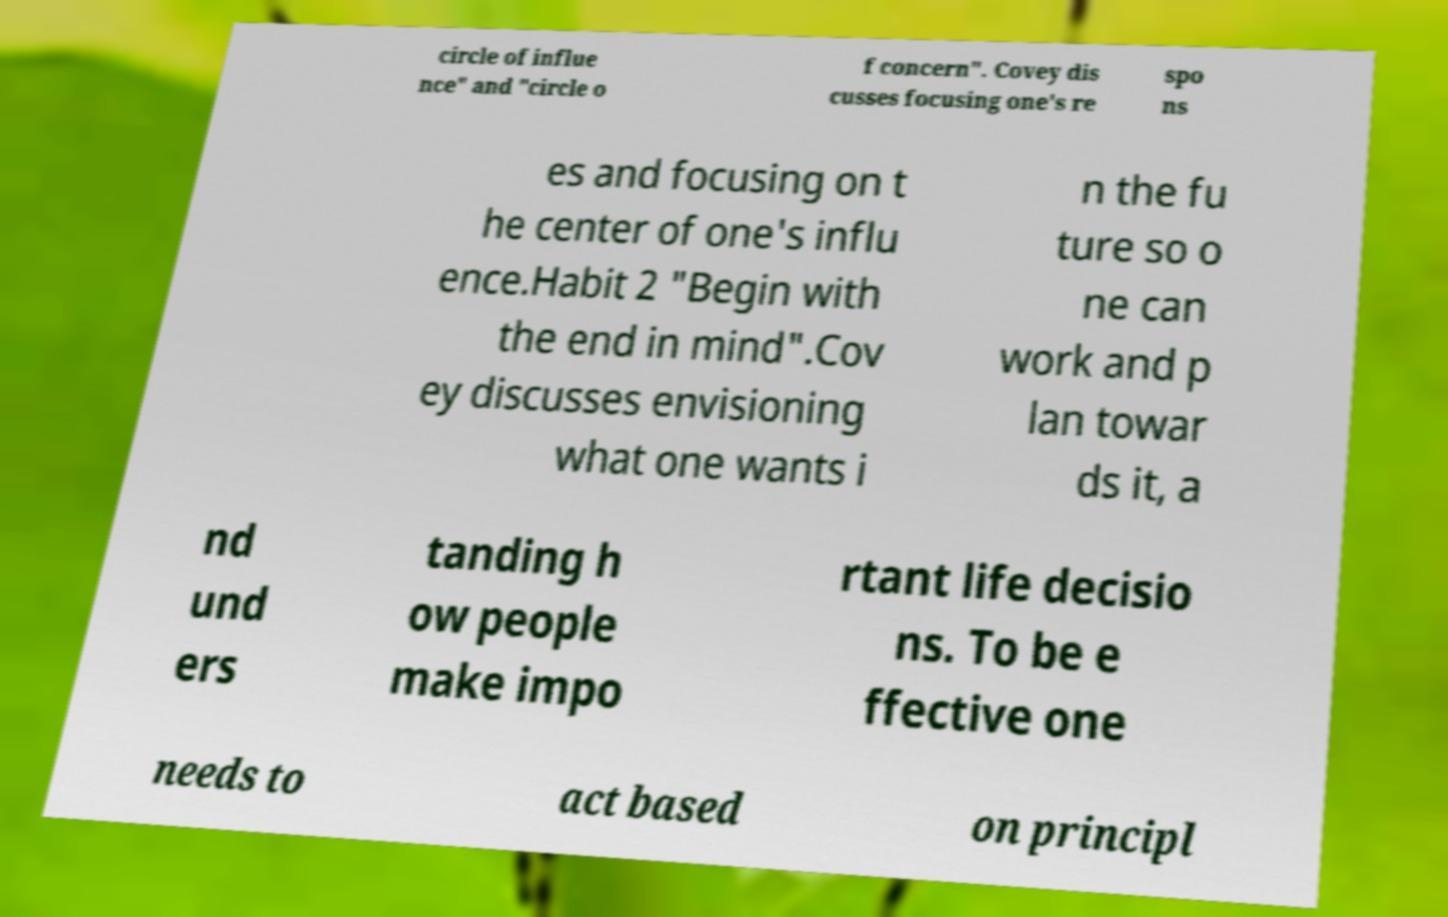Please read and relay the text visible in this image. What does it say? circle of influe nce" and "circle o f concern". Covey dis cusses focusing one's re spo ns es and focusing on t he center of one's influ ence.Habit 2 "Begin with the end in mind".Cov ey discusses envisioning what one wants i n the fu ture so o ne can work and p lan towar ds it, a nd und ers tanding h ow people make impo rtant life decisio ns. To be e ffective one needs to act based on principl 